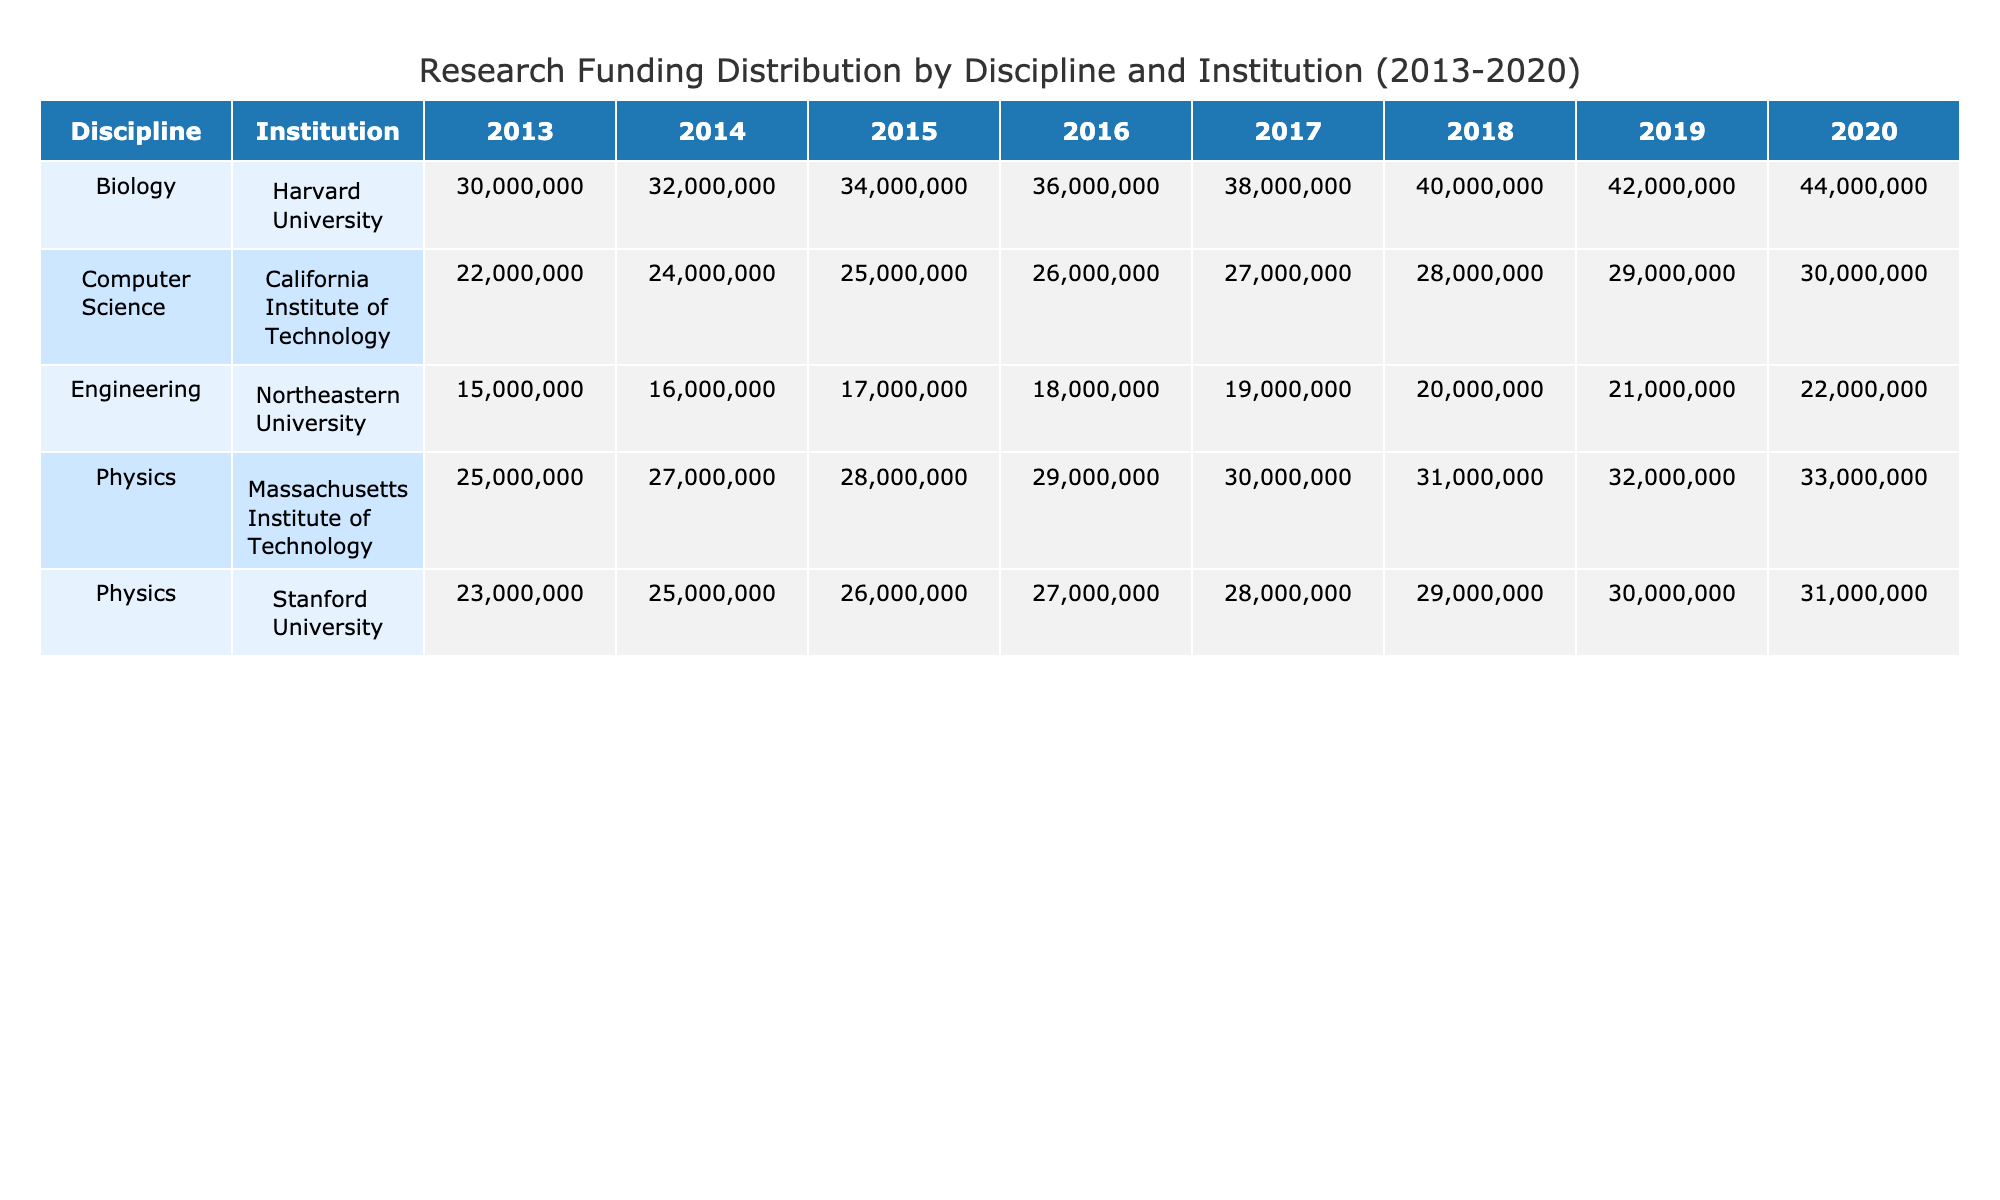What was the total funding amount for Physics at the Massachusetts Institute of Technology in 2019? The funding amount for Physics at the Massachusetts Institute of Technology in 2019 is found in the corresponding row and column of the table. The value is 33,000,000 USD.
Answer: 33000000 Which discipline received the highest total funding in 2018? To determine the highest total funding for a discipline in 2018, sum the funding amounts for each discipline specifically for that year. The results are: Physics (31,000,000), Biology (40,000,000), Computer Science (28,000,000), and Engineering (20,000,000). The maximum is 40,000,000 for Biology.
Answer: Biology Did Stanford University receive more funding than the California Institute of Technology (Caltech) for Computer Science in 2016? Compare the two values for Computer Science in 2016. Stanford University received 26,000,000 USD, while Caltech received 26,000,000 USD as well. Since the values are equal, the answer is false.
Answer: No What was the average funding amount for Biology over the years from 2013 to 2020? To find the average funding for Biology, sum the amounts received each year: 30,000,000 (2013) + 32,000,000 (2014) + 34,000,000 (2015) + 36,000,000 (2016) + 38,000,000 (2017) + 40,000,000 (2018) + 42,000,000 (2019) + 44,000,000 (2020) = 296,000,000. Then, divide this total by the 8 years: 296,000,000 / 8 = 37,000,000.
Answer: 37000000 What is the trend of funding for Engineering at Northeastern University from 2013 to 2020? To analyze the trend, examine the amounts per year from the table: 15,000,000 (2013), 16,000,000 (2014), 17,000,000 (2015), 18,000,000 (2016), 19,000,000 (2017), 20,000,000 (2018), 21,000,000 (2019), and 22,000,000 (2020). All values increase, indicating a positive trend.
Answer: Positive trend How much more funding did Biology at Harvard University receive in 2020 compared to Biology at Stanford University in the same year? First, identify the funding amounts: Biology at Harvard University in 2020 received 44,000,000 USD, while Biology at Stanford University received no funding (0 USD). The difference is 44,000,000 - 0 = 44,000,000 USD.
Answer: 44000000 